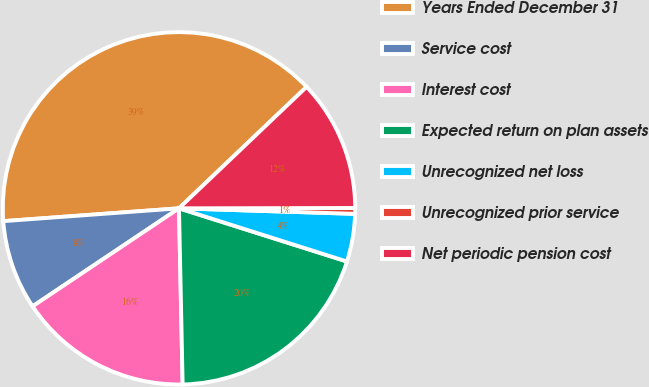<chart> <loc_0><loc_0><loc_500><loc_500><pie_chart><fcel>Years Ended December 31<fcel>Service cost<fcel>Interest cost<fcel>Expected return on plan assets<fcel>Unrecognized net loss<fcel>Unrecognized prior service<fcel>Net periodic pension cost<nl><fcel>39.05%<fcel>8.23%<fcel>15.94%<fcel>19.79%<fcel>4.38%<fcel>0.53%<fcel>12.08%<nl></chart> 